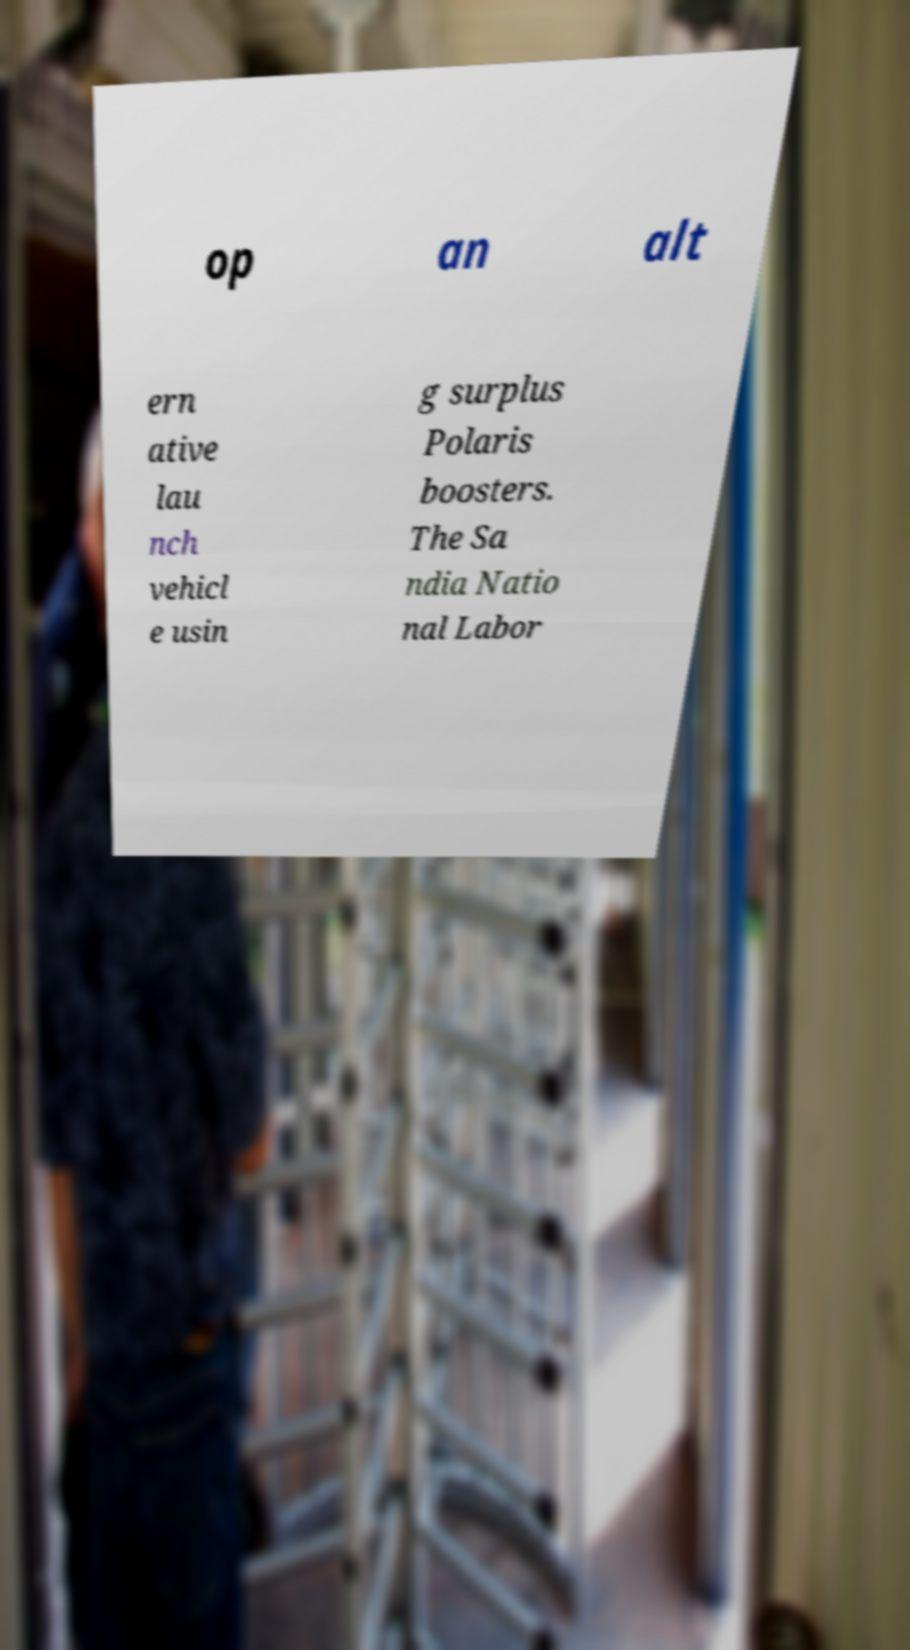Could you assist in decoding the text presented in this image and type it out clearly? op an alt ern ative lau nch vehicl e usin g surplus Polaris boosters. The Sa ndia Natio nal Labor 